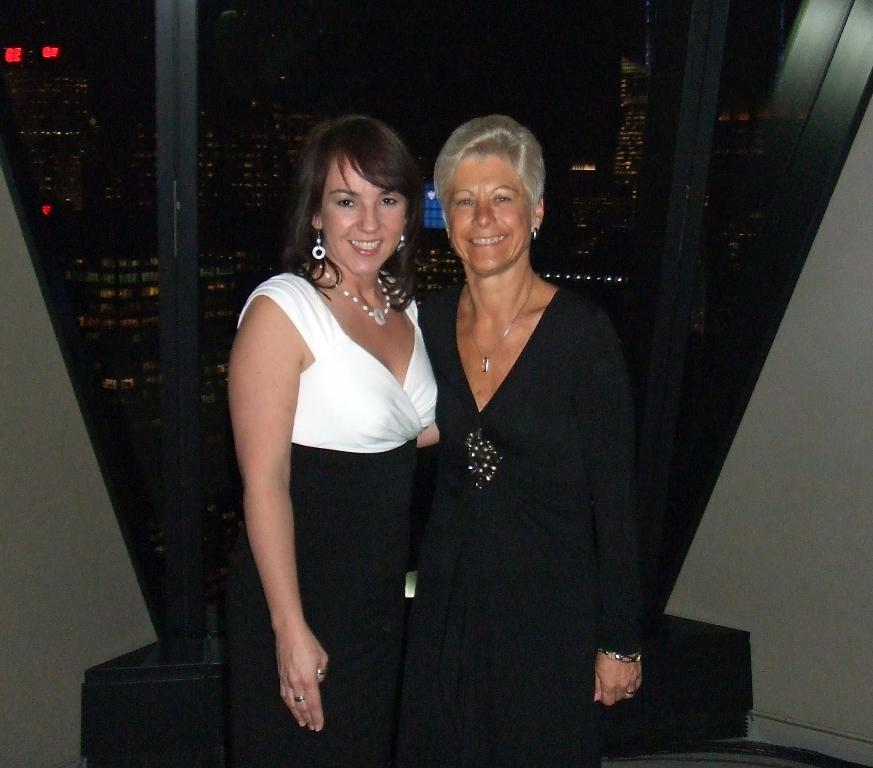How many women are in the image? There are two women in the image. What are the women doing in the image? The women are standing and smiling. What can be seen through the glass objects in the image? Buildings and lights are visible through the glass objects. What type of objects are made of glass in the image? There are glass objects in the image. How many children are playing with the board and clock in the image? There are no children, board, or clock present in the image. 